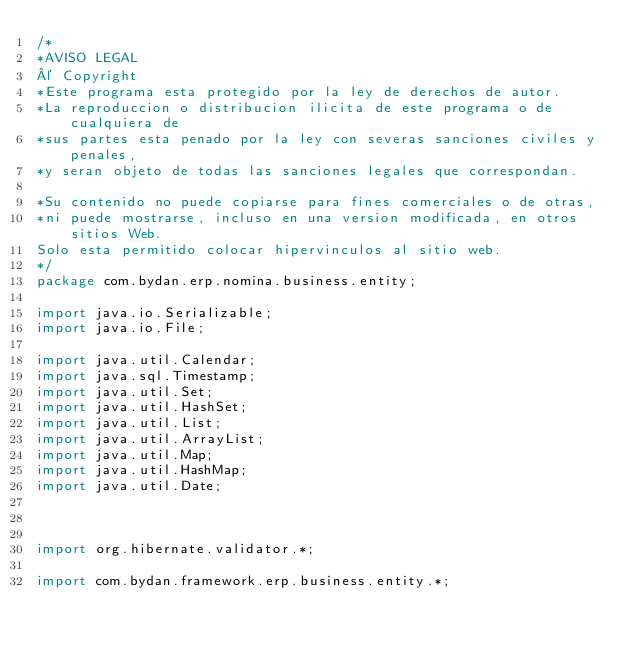<code> <loc_0><loc_0><loc_500><loc_500><_Java_>/*
*AVISO LEGAL
© Copyright
*Este programa esta protegido por la ley de derechos de autor.
*La reproduccion o distribucion ilicita de este programa o de cualquiera de
*sus partes esta penado por la ley con severas sanciones civiles y penales,
*y seran objeto de todas las sanciones legales que correspondan.

*Su contenido no puede copiarse para fines comerciales o de otras,
*ni puede mostrarse, incluso en una version modificada, en otros sitios Web.
Solo esta permitido colocar hipervinculos al sitio web.
*/
package com.bydan.erp.nomina.business.entity;

import java.io.Serializable;
import java.io.File;

import java.util.Calendar;
import java.sql.Timestamp;
import java.util.Set;
import java.util.HashSet;
import java.util.List;
import java.util.ArrayList;
import java.util.Map;
import java.util.HashMap;
import java.util.Date;



import org.hibernate.validator.*;

import com.bydan.framework.erp.business.entity.*;</code> 